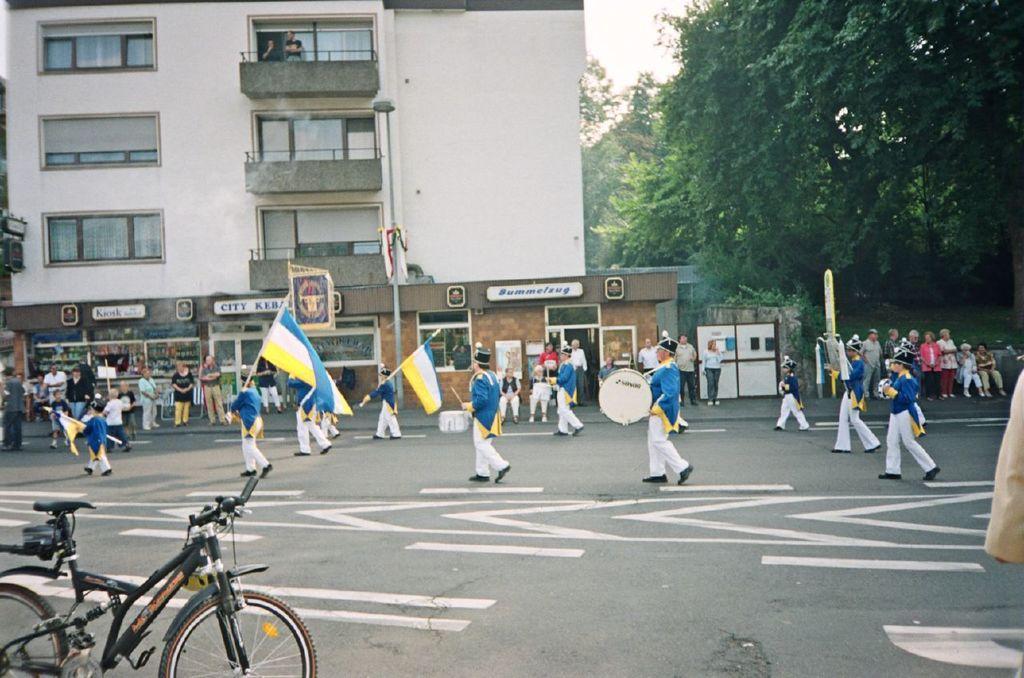In one or two sentences, can you explain what this image depicts? In this image there is a road at the bottom. On the road there are few people who are holding the flowers, while other people are playing the drums. In the background there is a building. On the right side top there are trees. There are few people standing on the footpath and watching the band. On the left side bottom there is a cycle on the road. 